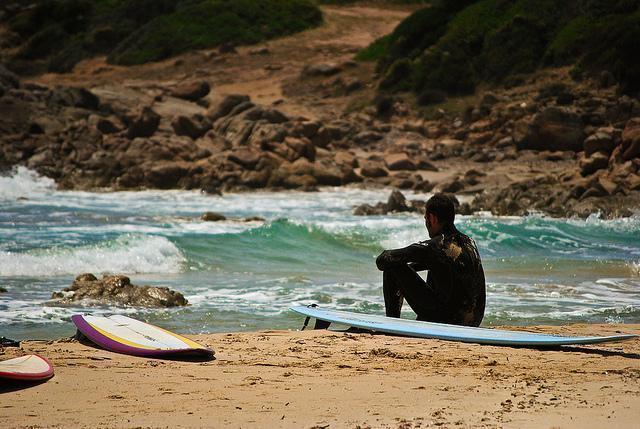What was the man just doing?
Select the accurate answer and provide justification: `Answer: choice
Rationale: srationale.`
Options: Swimming, lying down, running, sunbathing. Answer: lying down.
Rationale: The man is lying down. 